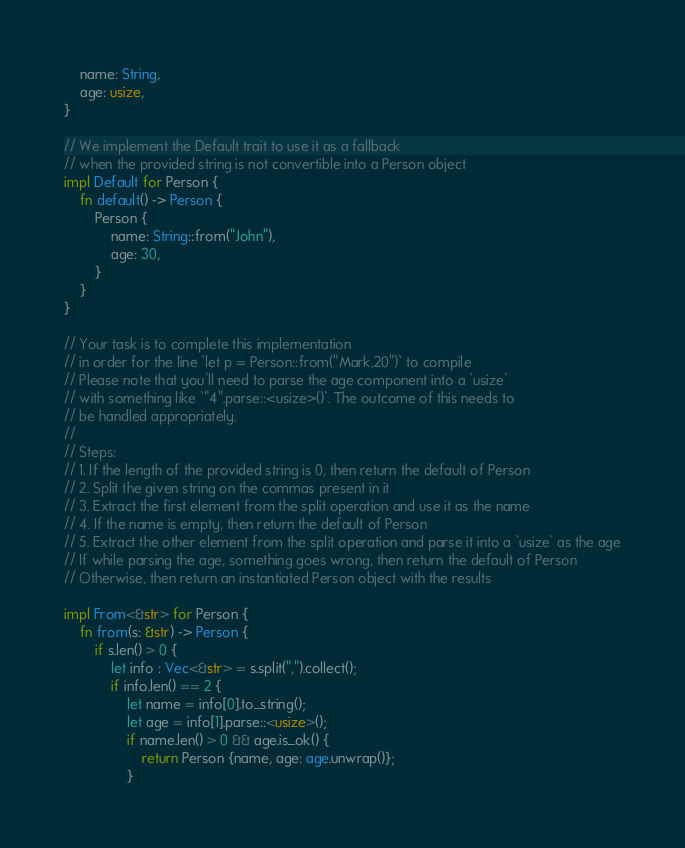Convert code to text. <code><loc_0><loc_0><loc_500><loc_500><_Rust_>    name: String,
    age: usize,
}

// We implement the Default trait to use it as a fallback
// when the provided string is not convertible into a Person object
impl Default for Person {
    fn default() -> Person {
        Person {
            name: String::from("John"),
            age: 30,
        }
    }
}

// Your task is to complete this implementation
// in order for the line `let p = Person::from("Mark,20")` to compile
// Please note that you'll need to parse the age component into a `usize`
// with something like `"4".parse::<usize>()`. The outcome of this needs to
// be handled appropriately.
//
// Steps:
// 1. If the length of the provided string is 0, then return the default of Person
// 2. Split the given string on the commas present in it
// 3. Extract the first element from the split operation and use it as the name
// 4. If the name is empty, then return the default of Person
// 5. Extract the other element from the split operation and parse it into a `usize` as the age
// If while parsing the age, something goes wrong, then return the default of Person
// Otherwise, then return an instantiated Person object with the results

impl From<&str> for Person {
    fn from(s: &str) -> Person {
        if s.len() > 0 {
            let info : Vec<&str> = s.split(",").collect();
            if info.len() == 2 {
                let name = info[0].to_string();
                let age = info[1].parse::<usize>();
                if name.len() > 0 && age.is_ok() {
                    return Person {name, age: age.unwrap()};
                }</code> 